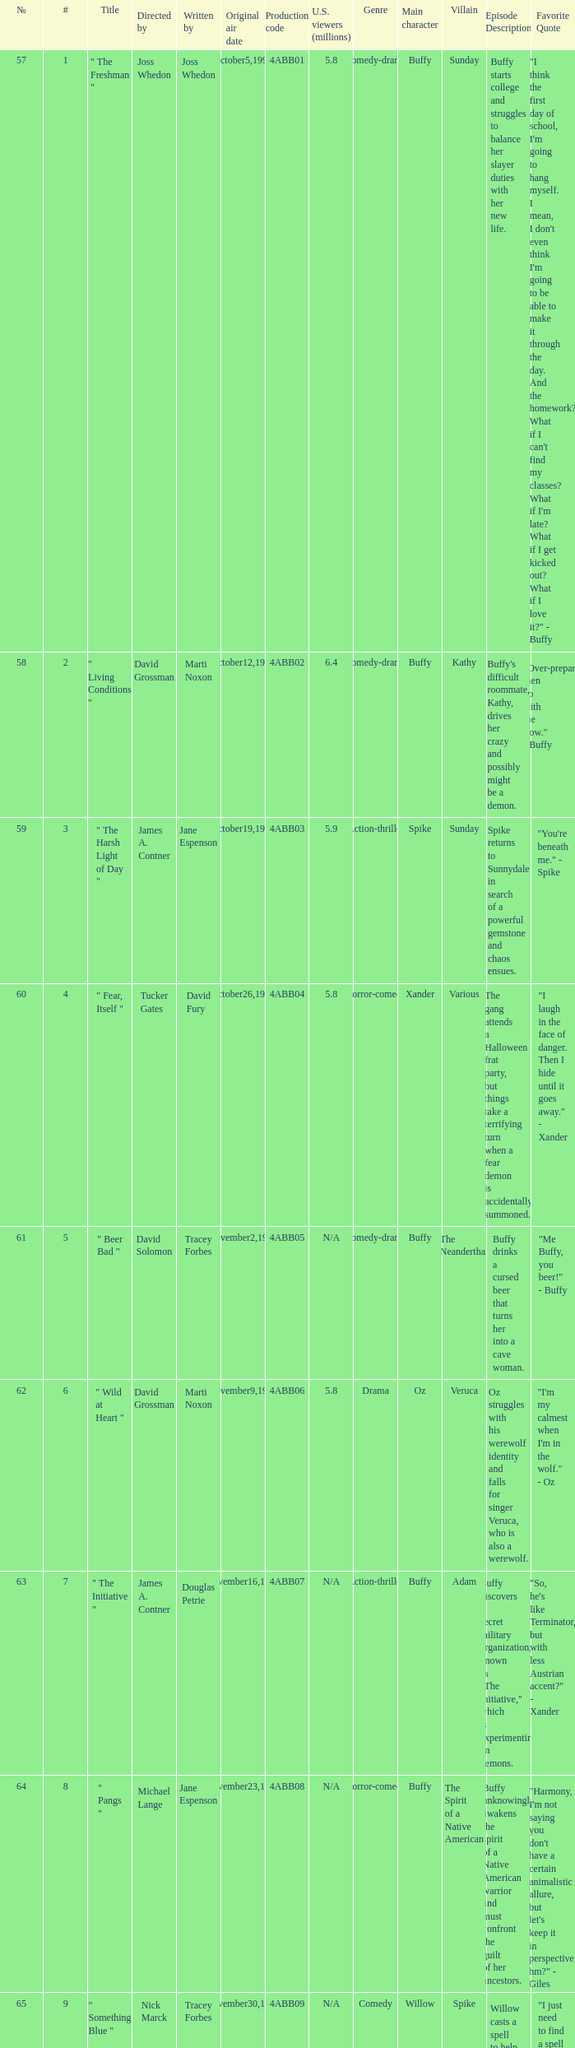What is the title of episode No. 65? " Something Blue ". 